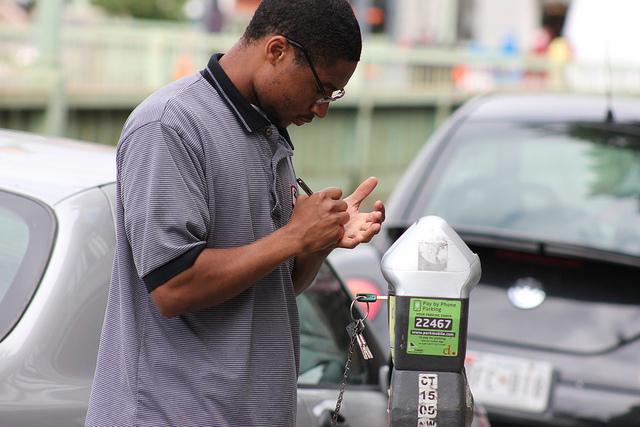What is the key for?
Quick response, please. Opening meter. Is the man a police officer?
Keep it brief. No. Why is a key in the meter?
Quick response, please. To open it. 